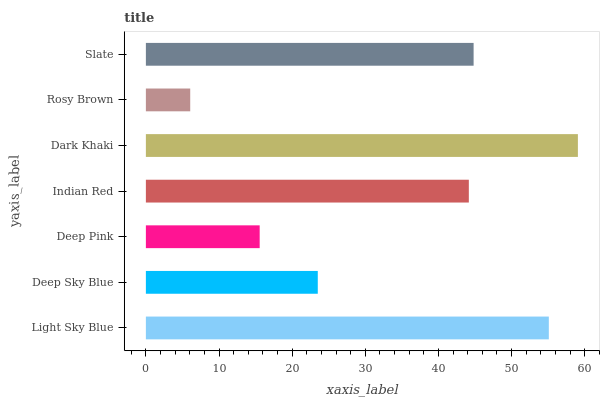Is Rosy Brown the minimum?
Answer yes or no. Yes. Is Dark Khaki the maximum?
Answer yes or no. Yes. Is Deep Sky Blue the minimum?
Answer yes or no. No. Is Deep Sky Blue the maximum?
Answer yes or no. No. Is Light Sky Blue greater than Deep Sky Blue?
Answer yes or no. Yes. Is Deep Sky Blue less than Light Sky Blue?
Answer yes or no. Yes. Is Deep Sky Blue greater than Light Sky Blue?
Answer yes or no. No. Is Light Sky Blue less than Deep Sky Blue?
Answer yes or no. No. Is Indian Red the high median?
Answer yes or no. Yes. Is Indian Red the low median?
Answer yes or no. Yes. Is Deep Sky Blue the high median?
Answer yes or no. No. Is Rosy Brown the low median?
Answer yes or no. No. 